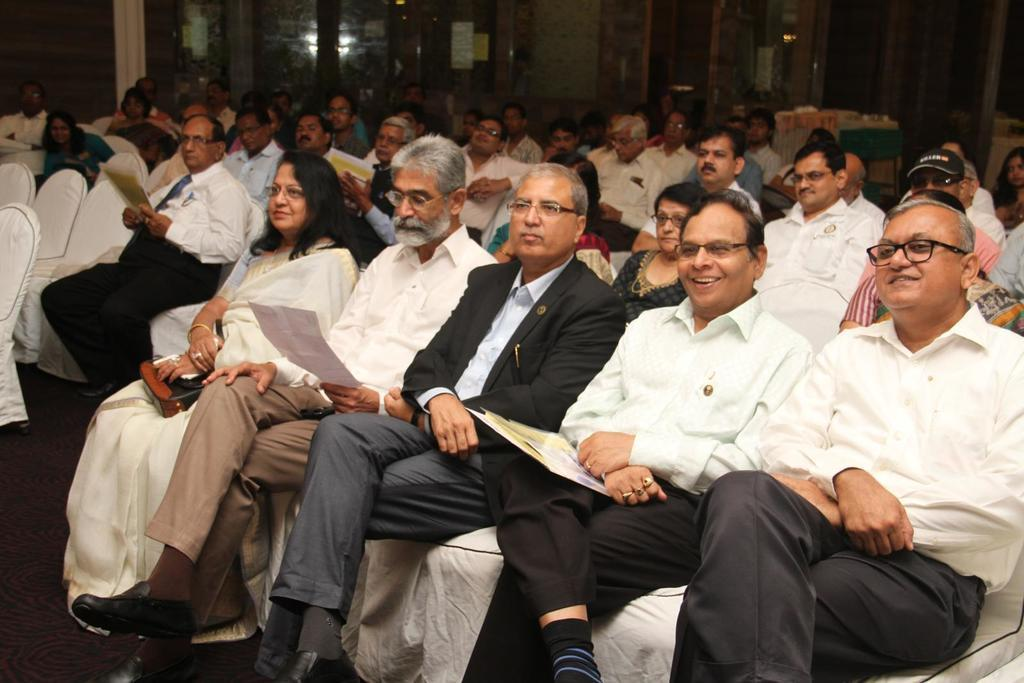What are the persons in the room doing? The persons in the room are sitting on chairs. What might the persons be holding in their hands? Some of the persons are holding papers. Is there any quicksand in the room where the persons are sitting? No, there is no quicksand present in the room. What type of farm animals can be seen in the image? There are no farm animals present in the image. 